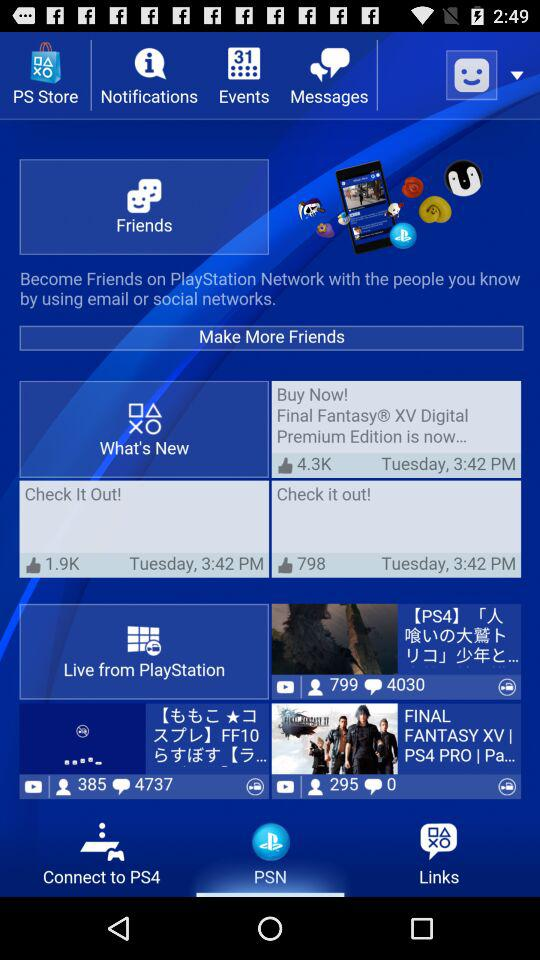What tab is selected? The selected tab is "PSN". 